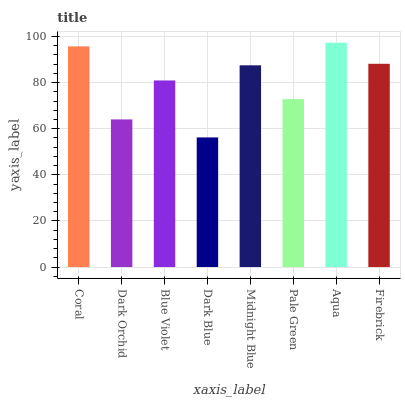Is Dark Blue the minimum?
Answer yes or no. Yes. Is Aqua the maximum?
Answer yes or no. Yes. Is Dark Orchid the minimum?
Answer yes or no. No. Is Dark Orchid the maximum?
Answer yes or no. No. Is Coral greater than Dark Orchid?
Answer yes or no. Yes. Is Dark Orchid less than Coral?
Answer yes or no. Yes. Is Dark Orchid greater than Coral?
Answer yes or no. No. Is Coral less than Dark Orchid?
Answer yes or no. No. Is Midnight Blue the high median?
Answer yes or no. Yes. Is Blue Violet the low median?
Answer yes or no. Yes. Is Dark Blue the high median?
Answer yes or no. No. Is Midnight Blue the low median?
Answer yes or no. No. 